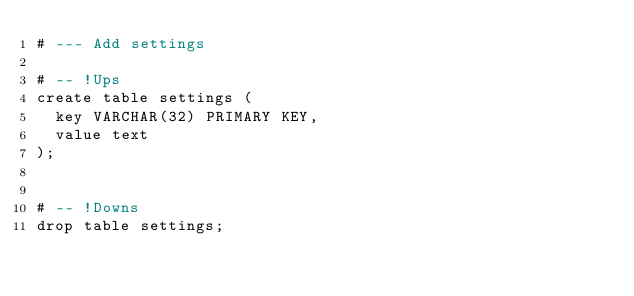Convert code to text. <code><loc_0><loc_0><loc_500><loc_500><_SQL_># --- Add settings

# -- !Ups
create table settings (
  key VARCHAR(32) PRIMARY KEY,
  value text
);


# -- !Downs
drop table settings;

</code> 